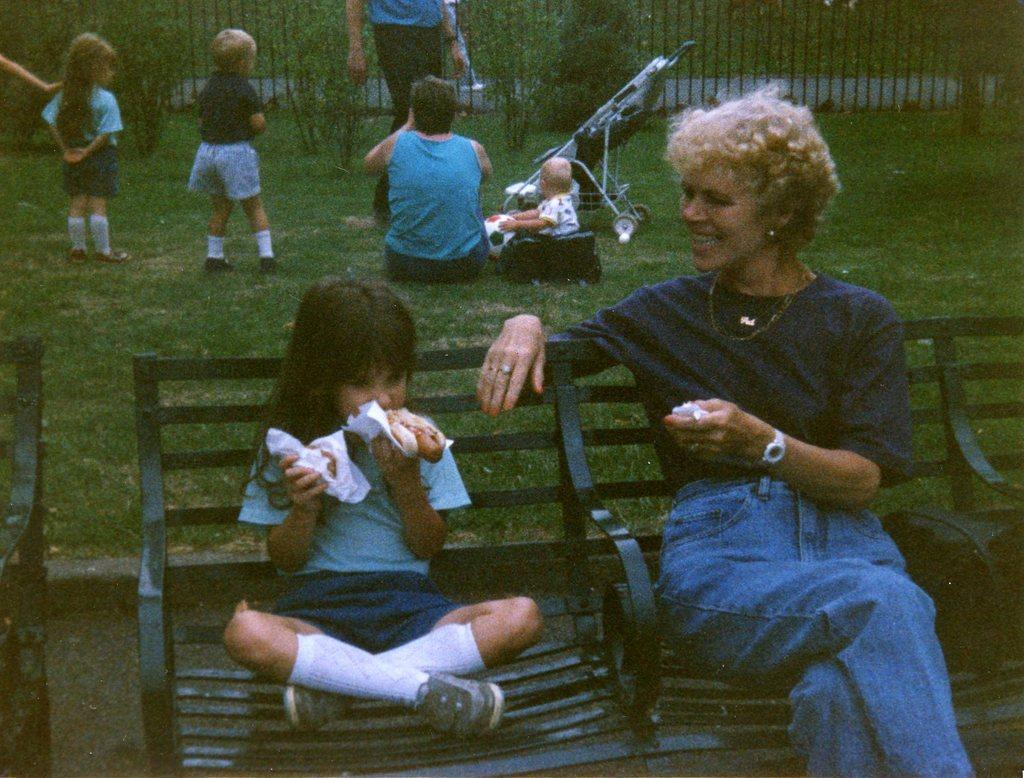How many people are sitting on the bench in the image? There are two people sitting on the bench in the image. What can be seen in the background of the image? In the background, there are kids and other people on a grass surface. What is located behind the people sitting on the bench? There is a fencing behind the people. What type of pizzas are the moms eating in the image? There is no mention of moms or pizzas in the image, so we cannot answer this question. 